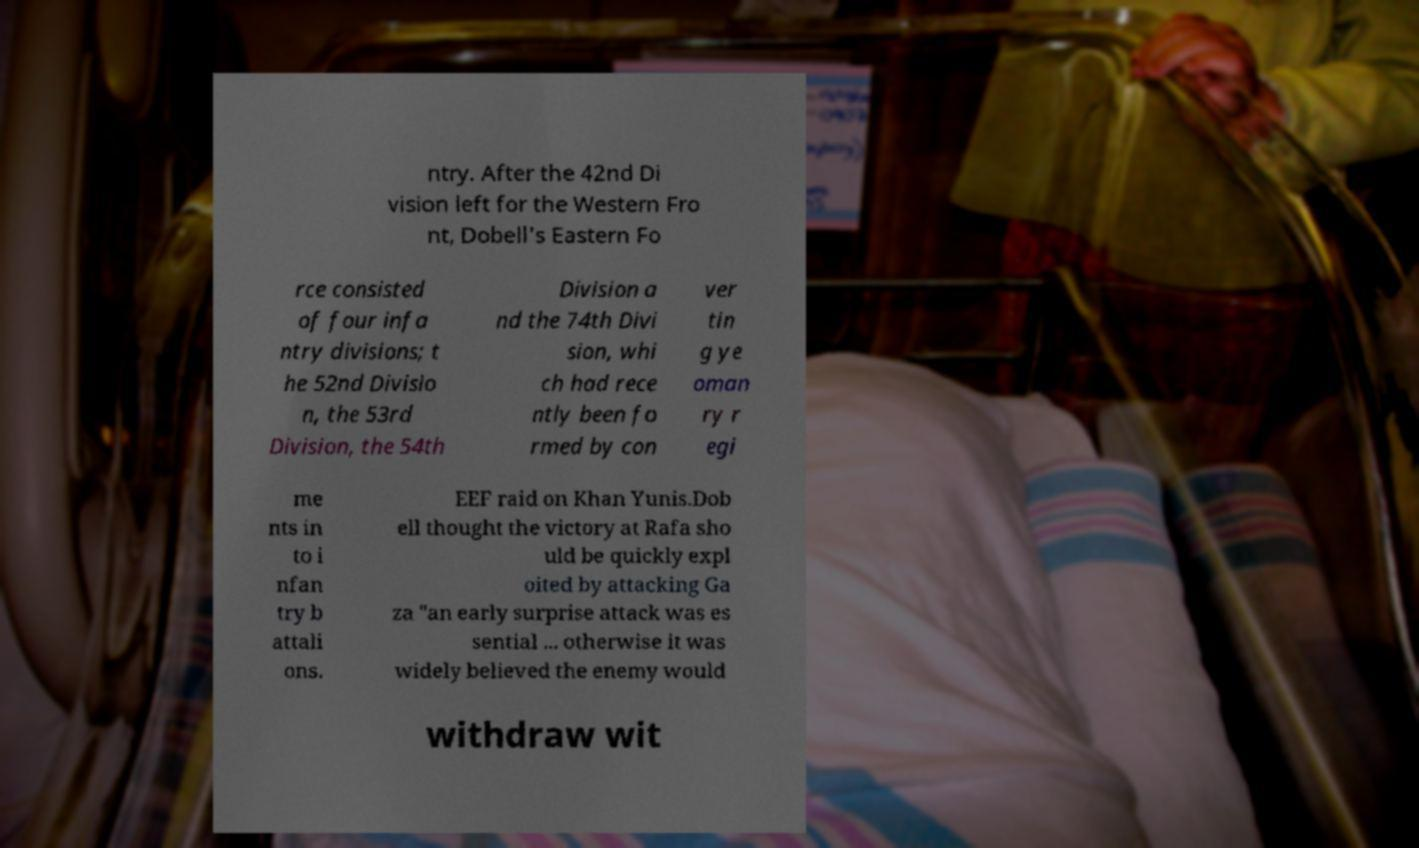I need the written content from this picture converted into text. Can you do that? ntry. After the 42nd Di vision left for the Western Fro nt, Dobell's Eastern Fo rce consisted of four infa ntry divisions; t he 52nd Divisio n, the 53rd Division, the 54th Division a nd the 74th Divi sion, whi ch had rece ntly been fo rmed by con ver tin g ye oman ry r egi me nts in to i nfan try b attali ons. EEF raid on Khan Yunis.Dob ell thought the victory at Rafa sho uld be quickly expl oited by attacking Ga za "an early surprise attack was es sential ... otherwise it was widely believed the enemy would withdraw wit 